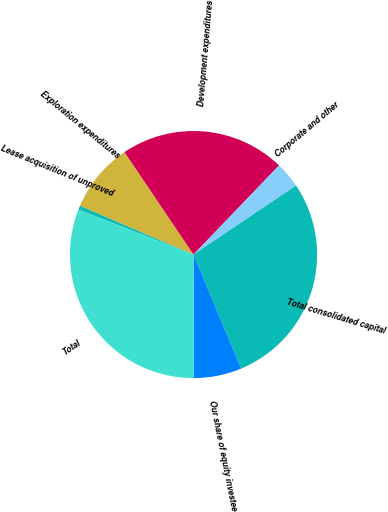Convert chart. <chart><loc_0><loc_0><loc_500><loc_500><pie_chart><fcel>Lease acquisition of unproved<fcel>Exploration expenditures<fcel>Development expenditures<fcel>Corporate and other<fcel>Total consolidated capital<fcel>Our share of equity investee<fcel>Total<nl><fcel>0.55%<fcel>9.09%<fcel>21.61%<fcel>3.4%<fcel>28.13%<fcel>6.24%<fcel>30.98%<nl></chart> 